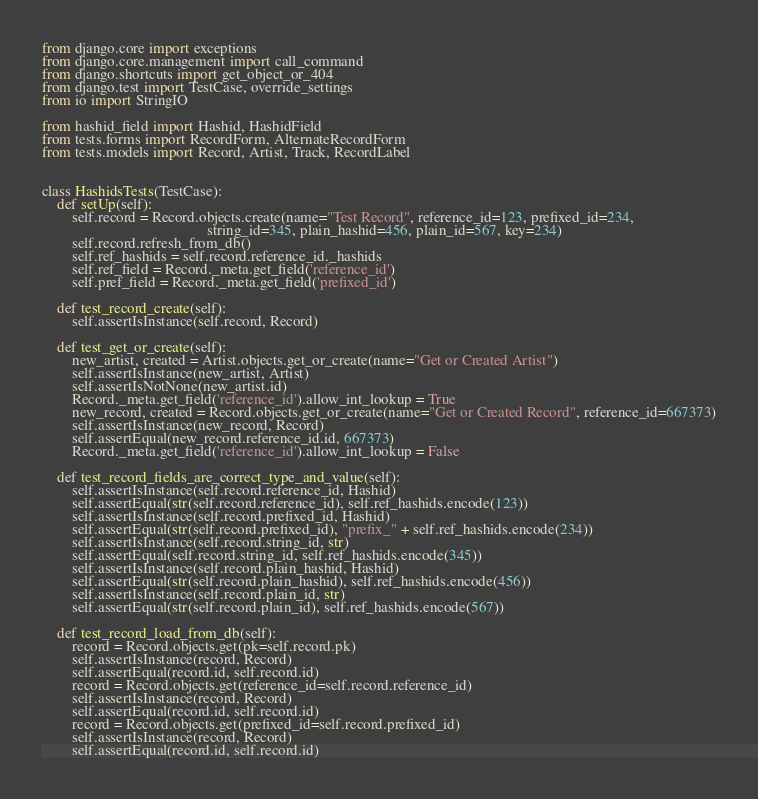<code> <loc_0><loc_0><loc_500><loc_500><_Python_>from django.core import exceptions
from django.core.management import call_command
from django.shortcuts import get_object_or_404
from django.test import TestCase, override_settings
from io import StringIO

from hashid_field import Hashid, HashidField
from tests.forms import RecordForm, AlternateRecordForm
from tests.models import Record, Artist, Track, RecordLabel


class HashidsTests(TestCase):
    def setUp(self):
        self.record = Record.objects.create(name="Test Record", reference_id=123, prefixed_id=234,
                                            string_id=345, plain_hashid=456, plain_id=567, key=234)
        self.record.refresh_from_db()
        self.ref_hashids = self.record.reference_id._hashids
        self.ref_field = Record._meta.get_field('reference_id')
        self.pref_field = Record._meta.get_field('prefixed_id')

    def test_record_create(self):
        self.assertIsInstance(self.record, Record)

    def test_get_or_create(self):
        new_artist, created = Artist.objects.get_or_create(name="Get or Created Artist")
        self.assertIsInstance(new_artist, Artist)
        self.assertIsNotNone(new_artist.id)
        Record._meta.get_field('reference_id').allow_int_lookup = True
        new_record, created = Record.objects.get_or_create(name="Get or Created Record", reference_id=667373)
        self.assertIsInstance(new_record, Record)
        self.assertEqual(new_record.reference_id.id, 667373)
        Record._meta.get_field('reference_id').allow_int_lookup = False

    def test_record_fields_are_correct_type_and_value(self):
        self.assertIsInstance(self.record.reference_id, Hashid)
        self.assertEqual(str(self.record.reference_id), self.ref_hashids.encode(123))
        self.assertIsInstance(self.record.prefixed_id, Hashid)
        self.assertEqual(str(self.record.prefixed_id), "prefix_" + self.ref_hashids.encode(234))
        self.assertIsInstance(self.record.string_id, str)
        self.assertEqual(self.record.string_id, self.ref_hashids.encode(345))
        self.assertIsInstance(self.record.plain_hashid, Hashid)
        self.assertEqual(str(self.record.plain_hashid), self.ref_hashids.encode(456))
        self.assertIsInstance(self.record.plain_id, str)
        self.assertEqual(str(self.record.plain_id), self.ref_hashids.encode(567))

    def test_record_load_from_db(self):
        record = Record.objects.get(pk=self.record.pk)
        self.assertIsInstance(record, Record)
        self.assertEqual(record.id, self.record.id)
        record = Record.objects.get(reference_id=self.record.reference_id)
        self.assertIsInstance(record, Record)
        self.assertEqual(record.id, self.record.id)
        record = Record.objects.get(prefixed_id=self.record.prefixed_id)
        self.assertIsInstance(record, Record)
        self.assertEqual(record.id, self.record.id)</code> 